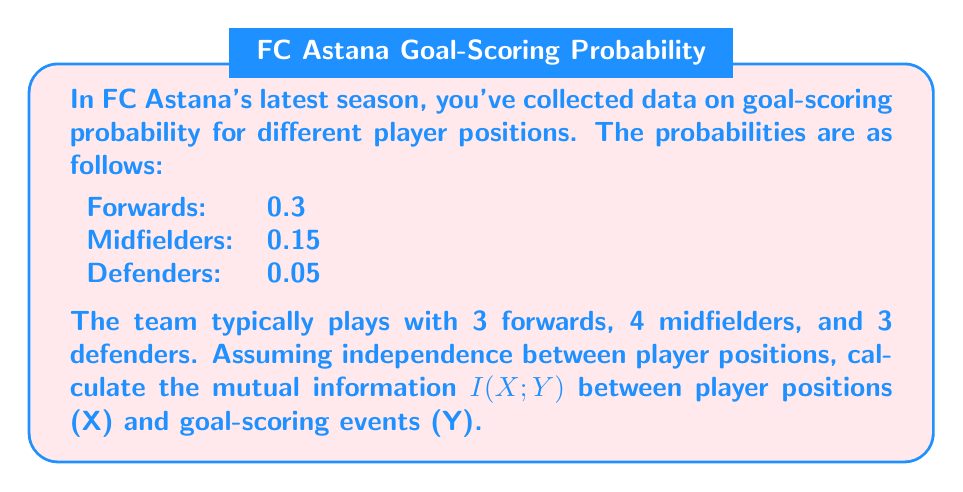Teach me how to tackle this problem. To solve this problem, we need to follow these steps:

1) First, let's calculate the probability distribution for player positions (X):
   P(X = Forward) = 3/10 = 0.3
   P(X = Midfielder) = 4/10 = 0.4
   P(X = Defender) = 3/10 = 0.3

2) Next, we need to calculate the probability of scoring a goal (Y = 1) and not scoring (Y = 0):
   P(Y = 1) = 0.3 * 0.3 + 0.4 * 0.15 + 0.3 * 0.05 = 0.09 + 0.06 + 0.015 = 0.165
   P(Y = 0) = 1 - 0.165 = 0.835

3) Now, we can calculate the joint probabilities P(X,Y):
   P(Forward, Y = 1) = 0.3 * 0.3 = 0.09
   P(Midfielder, Y = 1) = 0.4 * 0.15 = 0.06
   P(Defender, Y = 1) = 0.3 * 0.05 = 0.015
   P(Forward, Y = 0) = 0.3 - 0.09 = 0.21
   P(Midfielder, Y = 0) = 0.4 - 0.06 = 0.34
   P(Defender, Y = 0) = 0.3 - 0.015 = 0.285

4) The mutual information is given by:
   $$I(X;Y) = \sum_{x,y} P(x,y) \log_2 \frac{P(x,y)}{P(x)P(y)}$$

5) Let's calculate each term:
   $$0.09 \log_2 \frac{0.09}{0.3 * 0.165} + 0.06 \log_2 \frac{0.06}{0.4 * 0.165} + 0.015 \log_2 \frac{0.015}{0.3 * 0.165}$$
   $$+ 0.21 \log_2 \frac{0.21}{0.3 * 0.835} + 0.34 \log_2 \frac{0.34}{0.4 * 0.835} + 0.285 \log_2 \frac{0.285}{0.3 * 0.835}$$

6) Calculating these terms:
   0.09 * 0.8703 + 0.06 * (-0.1844) + 0.015 * (-1.7370)
   + 0.21 * (-0.1570) + 0.34 * 0.0304 + 0.285 * 0.2863
   = 0.07833 - 0.01106 - 0.02606 - 0.03297 + 0.01034 + 0.08160
   = 0.10018 bits

Therefore, the mutual information I(X;Y) is approximately 0.10018 bits.
Answer: The mutual information I(X;Y) between player positions and goal-scoring events is approximately 0.10018 bits. 